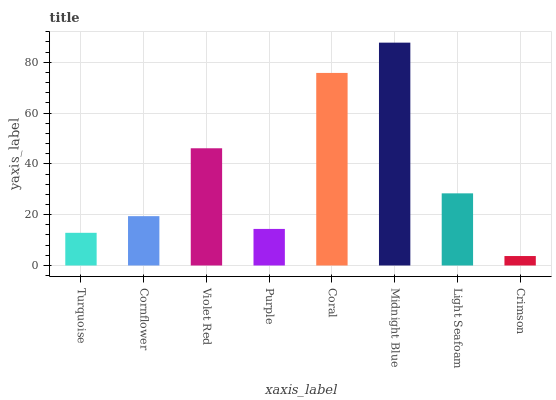Is Crimson the minimum?
Answer yes or no. Yes. Is Midnight Blue the maximum?
Answer yes or no. Yes. Is Cornflower the minimum?
Answer yes or no. No. Is Cornflower the maximum?
Answer yes or no. No. Is Cornflower greater than Turquoise?
Answer yes or no. Yes. Is Turquoise less than Cornflower?
Answer yes or no. Yes. Is Turquoise greater than Cornflower?
Answer yes or no. No. Is Cornflower less than Turquoise?
Answer yes or no. No. Is Light Seafoam the high median?
Answer yes or no. Yes. Is Cornflower the low median?
Answer yes or no. Yes. Is Turquoise the high median?
Answer yes or no. No. Is Coral the low median?
Answer yes or no. No. 